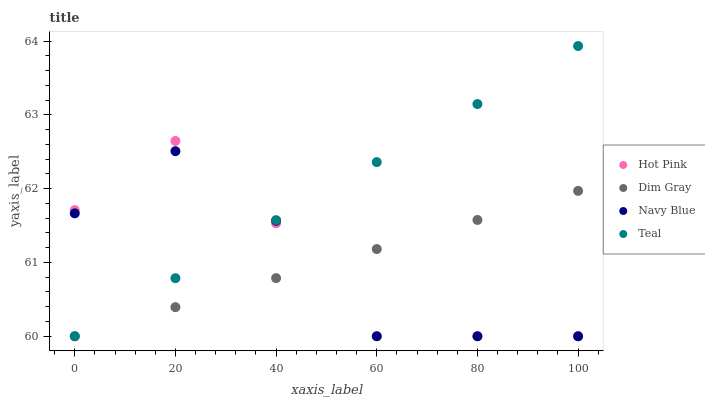Does Navy Blue have the minimum area under the curve?
Answer yes or no. Yes. Does Teal have the maximum area under the curve?
Answer yes or no. Yes. Does Dim Gray have the minimum area under the curve?
Answer yes or no. No. Does Dim Gray have the maximum area under the curve?
Answer yes or no. No. Is Dim Gray the smoothest?
Answer yes or no. Yes. Is Hot Pink the roughest?
Answer yes or no. Yes. Is Hot Pink the smoothest?
Answer yes or no. No. Is Dim Gray the roughest?
Answer yes or no. No. Does Navy Blue have the lowest value?
Answer yes or no. Yes. Does Teal have the highest value?
Answer yes or no. Yes. Does Hot Pink have the highest value?
Answer yes or no. No. Does Navy Blue intersect Dim Gray?
Answer yes or no. Yes. Is Navy Blue less than Dim Gray?
Answer yes or no. No. Is Navy Blue greater than Dim Gray?
Answer yes or no. No. 